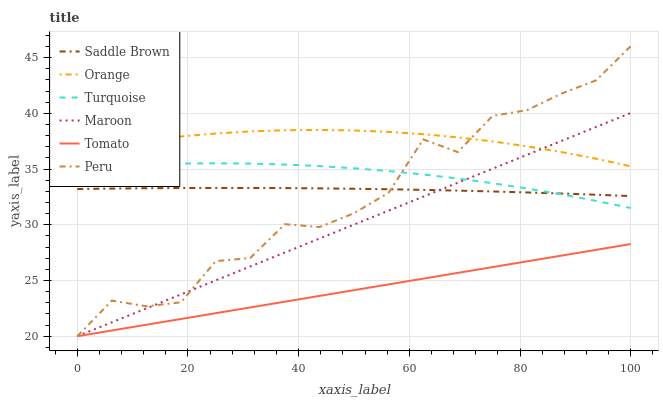Does Tomato have the minimum area under the curve?
Answer yes or no. Yes. Does Orange have the maximum area under the curve?
Answer yes or no. Yes. Does Turquoise have the minimum area under the curve?
Answer yes or no. No. Does Turquoise have the maximum area under the curve?
Answer yes or no. No. Is Maroon the smoothest?
Answer yes or no. Yes. Is Peru the roughest?
Answer yes or no. Yes. Is Turquoise the smoothest?
Answer yes or no. No. Is Turquoise the roughest?
Answer yes or no. No. Does Tomato have the lowest value?
Answer yes or no. Yes. Does Turquoise have the lowest value?
Answer yes or no. No. Does Peru have the highest value?
Answer yes or no. Yes. Does Turquoise have the highest value?
Answer yes or no. No. Is Tomato less than Saddle Brown?
Answer yes or no. Yes. Is Turquoise greater than Tomato?
Answer yes or no. Yes. Does Peru intersect Orange?
Answer yes or no. Yes. Is Peru less than Orange?
Answer yes or no. No. Is Peru greater than Orange?
Answer yes or no. No. Does Tomato intersect Saddle Brown?
Answer yes or no. No. 